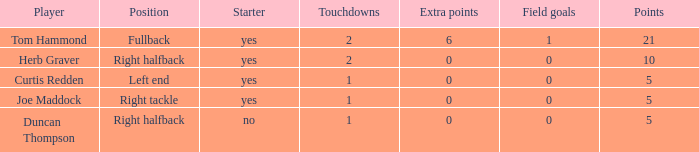Indicate the lowest touchdowns 1.0. 